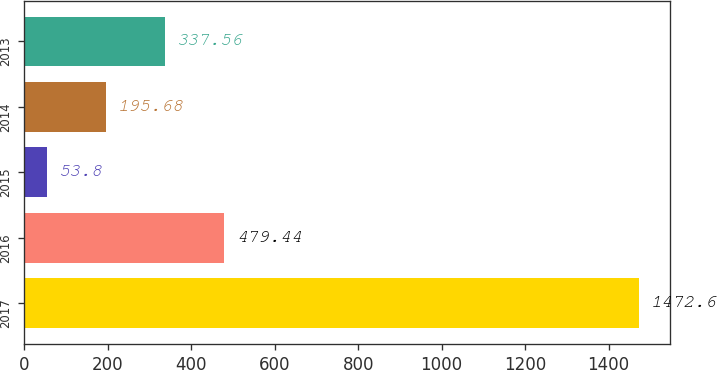Convert chart. <chart><loc_0><loc_0><loc_500><loc_500><bar_chart><fcel>2017<fcel>2016<fcel>2015<fcel>2014<fcel>2013<nl><fcel>1472.6<fcel>479.44<fcel>53.8<fcel>195.68<fcel>337.56<nl></chart> 